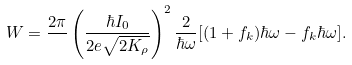Convert formula to latex. <formula><loc_0><loc_0><loc_500><loc_500>W = \frac { 2 \pi } { } \left ( \frac { \hbar { I } _ { 0 } } { 2 e \sqrt { 2 K _ { \rho } } } \right ) ^ { 2 } \frac { 2 } { \hbar { \omega } } [ ( 1 + f _ { k } ) \hbar { \omega } - f _ { k } \hbar { \omega } ] .</formula> 